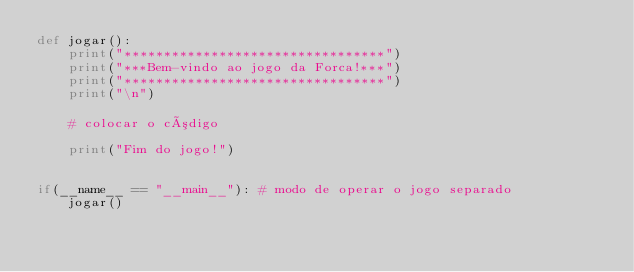<code> <loc_0><loc_0><loc_500><loc_500><_Python_>def jogar():
    print("*********************************")
    print("***Bem-vindo ao jogo da Forca!***")
    print("*********************************")
    print("\n")

    # colocar o código

    print("Fim do jogo!")


if(__name__ == "__main__"): # modo de operar o jogo separado
    jogar()</code> 